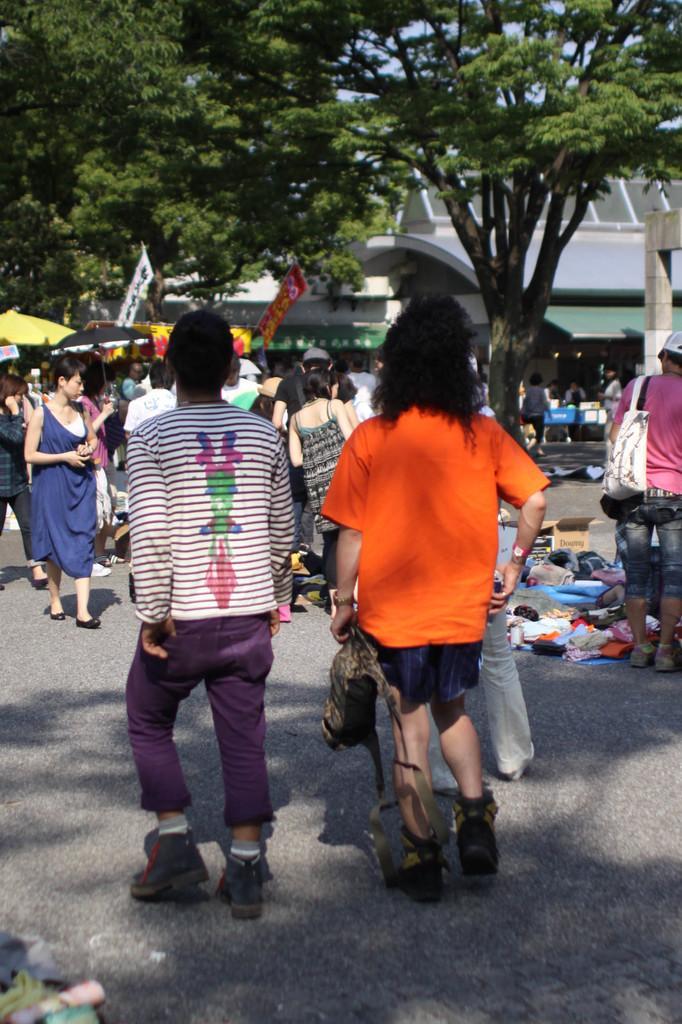In one or two sentences, can you explain what this image depicts? In this image, I can see a group of people standing and few people walking. On the right side of the image, I can see a cardboard box and clothes on the road. In the background, there are banners, trees and a building. There is a person holding an umbrella. 